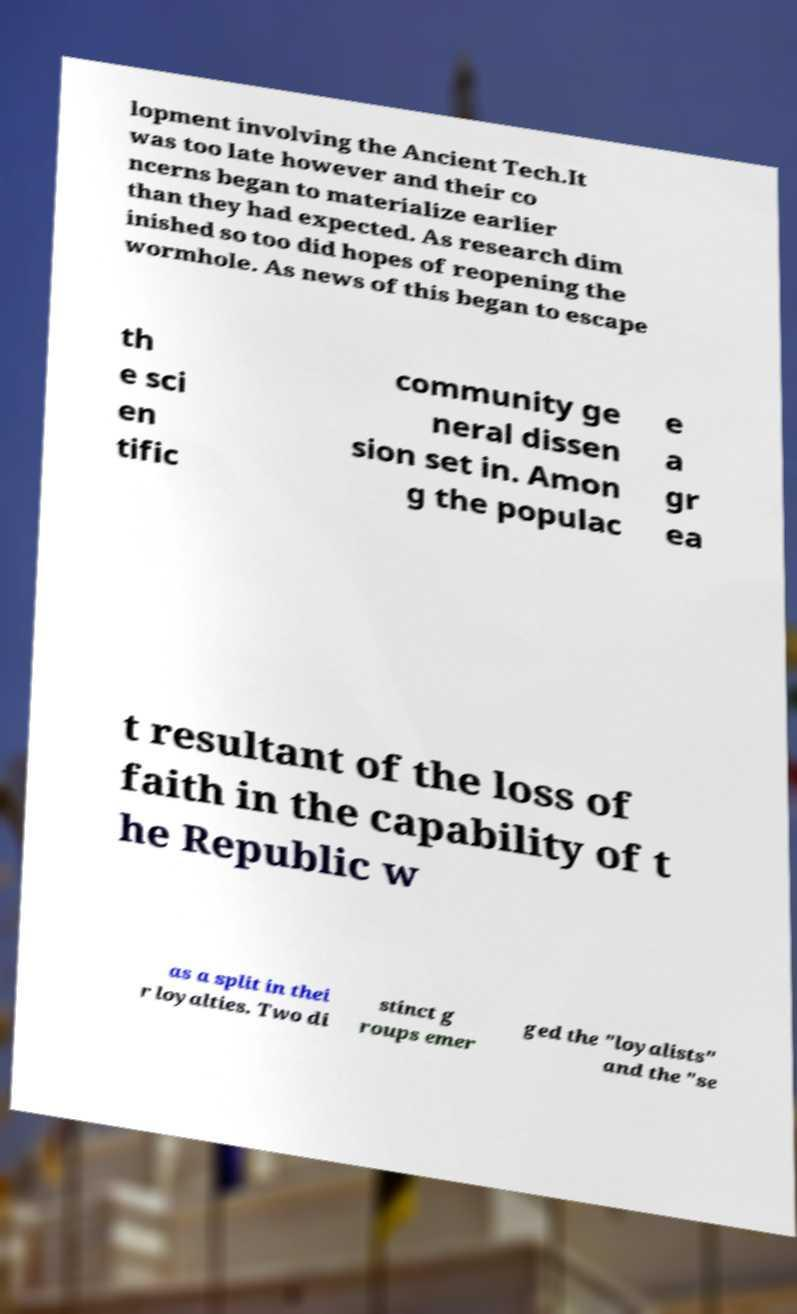Please read and relay the text visible in this image. What does it say? lopment involving the Ancient Tech.It was too late however and their co ncerns began to materialize earlier than they had expected. As research dim inished so too did hopes of reopening the wormhole. As news of this began to escape th e sci en tific community ge neral dissen sion set in. Amon g the populac e a gr ea t resultant of the loss of faith in the capability of t he Republic w as a split in thei r loyalties. Two di stinct g roups emer ged the "loyalists" and the "se 